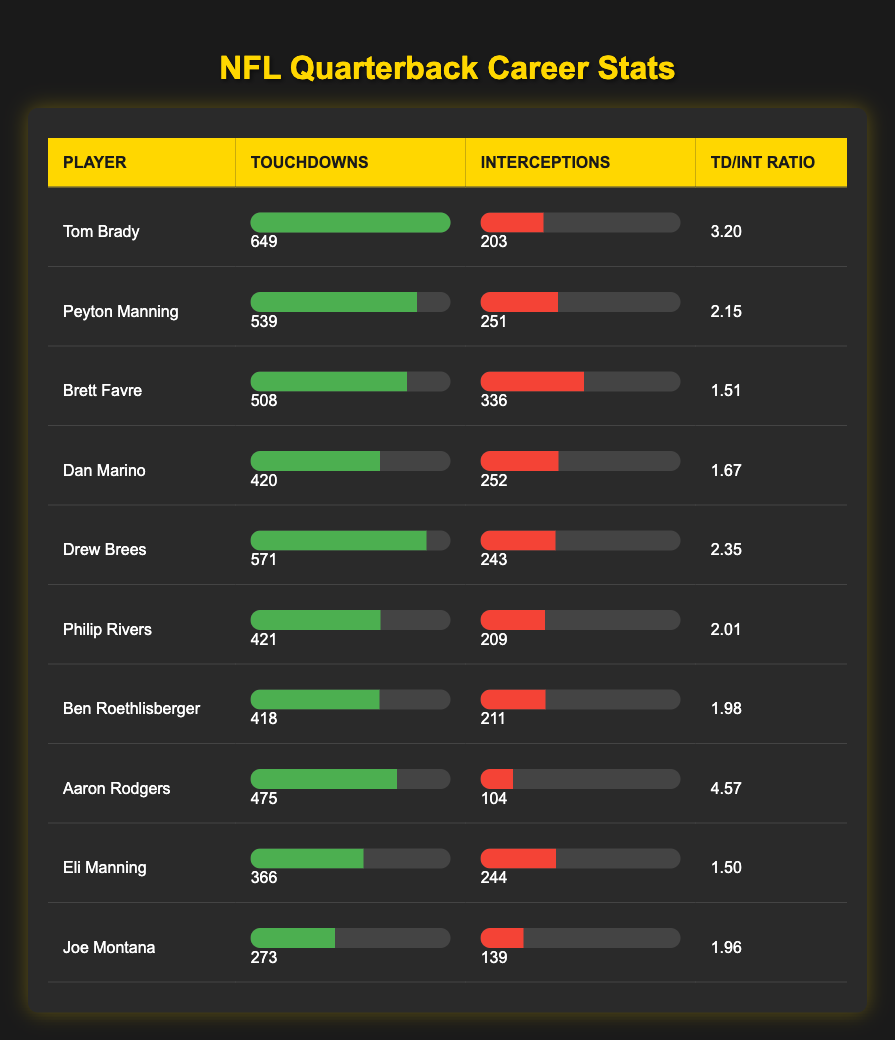What is Tom Brady's total number of touchdown passes? Tom Brady's row in the table shows a value of 649 for touchdowns, which is a direct retrieval of the data for this player.
Answer: 649 Which player has the highest touchdown to interception ratio? The touchdown to interception ratios can be calculated for each player. Upon reviewing the table, Aaron Rodgers has the highest ratio of 4.57, which is confirmed by comparing all ratios listed.
Answer: 4.57 How many interceptions did Drew Brees throw compared to Aaron Rodgers? Drew Brees threw 243 interceptions, while Aaron Rodgers threw 104. The specific values for interceptions for each player are found in their respective rows in the table.
Answer: Drew Brees: 243, Aaron Rodgers: 104 What is the total number of touchdowns and interceptions for all players combined? To find the total, sum the touchdowns and interceptions separately from the table: Total touchdowns = 649 + 539 + 508 + 420 + 571 + 421 + 418 + 475 + 366 + 273 = 5080; Total interceptions = 203 + 251 + 336 + 252 + 243 + 209 + 211 + 104 + 244 + 139 = 1888. Therefore, both totals are obtained from a simple addition.
Answer: Touchdowns: 5080, Interceptions: 1888 Is it true that Brett Favre threw more touchdowns than Dan Marino? Brett Favre has 508 touchdowns, whereas Dan Marino has 420 touchdowns. A straightforward comparison of these two values confirms that Brett Favre has indeed thrown more touchdowns than Dan Marino.
Answer: Yes What is the difference in the number of interceptions between Peyton Manning and Eli Manning? Peyton Manning threw 251 interceptions while Eli Manning threw 244. To find the difference, subtract Eli's interceptions from Peyton's: 251 - 244 = 7. The values needed for this calculation are located in their respective rows for interception counts.
Answer: 7 Which player scored more touchdowns, Philip Rivers or Ben Roethlisberger? Philip Rivers scored 421 touchdowns, while Ben Roethlisberger scored 418 touchdowns. A simple numeric comparison indicates that Philip Rivers has more touchdowns than Ben Roethlisberger.
Answer: Philip Rivers What is the average number of touchdowns for the quarterbacks listed? To calculate the average touchdowns, sum all touchdowns: 649 + 539 + 508 + 420 + 571 + 421 + 418 + 475 + 366 + 273 = 5080, then divide by the number of players (10): 5080 / 10 = 508. The calculation involves adding and then dividing the result by the number of players.
Answer: 508 How many players threw fewer than 200 interceptions? From the table, only two players, Tom Brady (203) and Peyton Manning (251), have more than 200 interceptions. This means that eight players threw fewer than 200 interceptions, which requires counting only those with intercepts below 200.
Answer: 8 Which player had both the lowest number of touchdowns and the lowest number of interceptions? By reviewing the table, Joe Montana has the lowest touchdowns (273) and the lowest interceptions (139). The answer is reached by comparing both touchdown and interception columns across all players to find the minimum values.
Answer: Joe Montana 